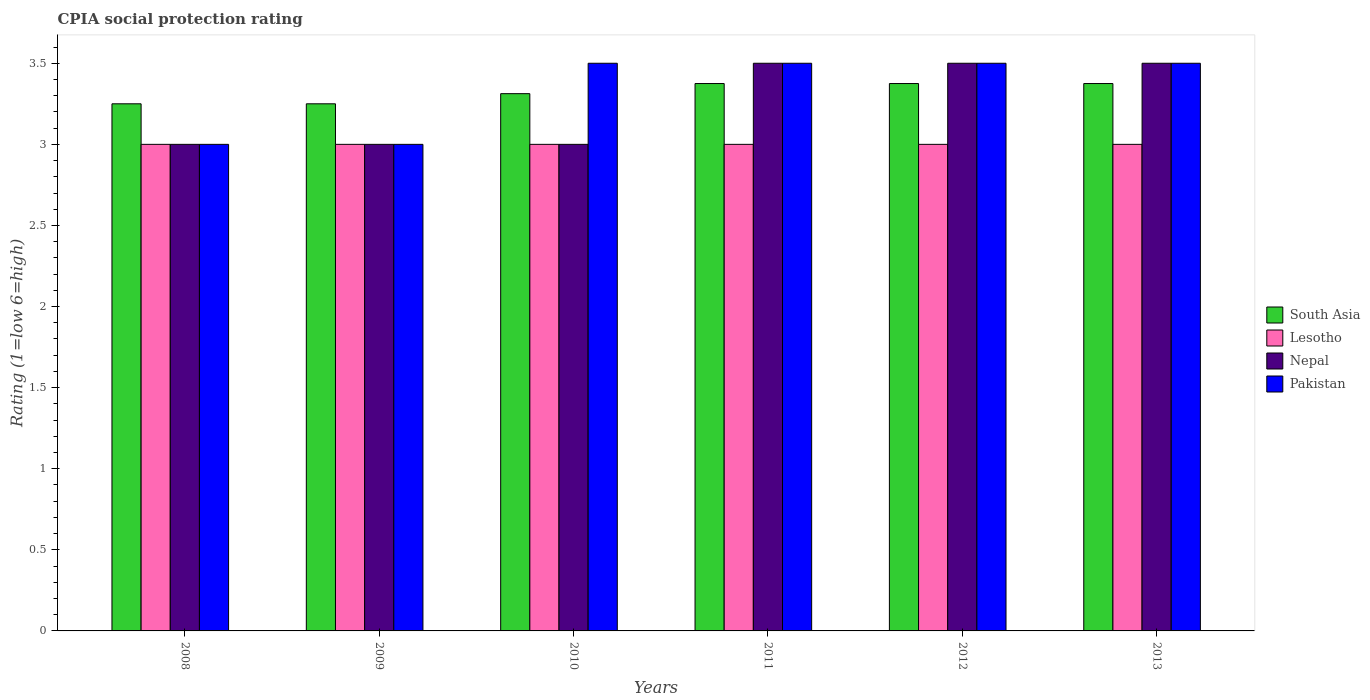How many groups of bars are there?
Your answer should be compact. 6. Are the number of bars per tick equal to the number of legend labels?
Ensure brevity in your answer.  Yes. How many bars are there on the 6th tick from the left?
Give a very brief answer. 4. What is the label of the 6th group of bars from the left?
Give a very brief answer. 2013. In how many cases, is the number of bars for a given year not equal to the number of legend labels?
Provide a succinct answer. 0. What is the CPIA rating in South Asia in 2013?
Give a very brief answer. 3.38. Across all years, what is the minimum CPIA rating in Lesotho?
Offer a very short reply. 3. In which year was the CPIA rating in Pakistan maximum?
Ensure brevity in your answer.  2010. What is the total CPIA rating in South Asia in the graph?
Make the answer very short. 19.94. What is the difference between the CPIA rating in South Asia in 2008 and that in 2012?
Your answer should be very brief. -0.12. What is the difference between the CPIA rating in Pakistan in 2011 and the CPIA rating in Nepal in 2009?
Your response must be concise. 0.5. What is the average CPIA rating in South Asia per year?
Offer a terse response. 3.32. In the year 2009, what is the difference between the CPIA rating in Lesotho and CPIA rating in Nepal?
Ensure brevity in your answer.  0. In how many years, is the CPIA rating in Pakistan greater than 2.3?
Offer a very short reply. 6. What is the ratio of the CPIA rating in Pakistan in 2010 to that in 2012?
Offer a very short reply. 1. What is the difference between the highest and the lowest CPIA rating in Pakistan?
Keep it short and to the point. 0.5. In how many years, is the CPIA rating in Lesotho greater than the average CPIA rating in Lesotho taken over all years?
Make the answer very short. 0. Is the sum of the CPIA rating in Lesotho in 2008 and 2011 greater than the maximum CPIA rating in Pakistan across all years?
Give a very brief answer. Yes. What does the 1st bar from the left in 2012 represents?
Your response must be concise. South Asia. What does the 1st bar from the right in 2009 represents?
Provide a short and direct response. Pakistan. Is it the case that in every year, the sum of the CPIA rating in Pakistan and CPIA rating in Lesotho is greater than the CPIA rating in South Asia?
Provide a short and direct response. Yes. How many years are there in the graph?
Your answer should be compact. 6. What is the difference between two consecutive major ticks on the Y-axis?
Provide a succinct answer. 0.5. How many legend labels are there?
Give a very brief answer. 4. What is the title of the graph?
Your answer should be compact. CPIA social protection rating. What is the Rating (1=low 6=high) in Pakistan in 2008?
Make the answer very short. 3. What is the Rating (1=low 6=high) of South Asia in 2009?
Your response must be concise. 3.25. What is the Rating (1=low 6=high) of South Asia in 2010?
Offer a terse response. 3.31. What is the Rating (1=low 6=high) in Lesotho in 2010?
Your response must be concise. 3. What is the Rating (1=low 6=high) in South Asia in 2011?
Your response must be concise. 3.38. What is the Rating (1=low 6=high) in Nepal in 2011?
Offer a terse response. 3.5. What is the Rating (1=low 6=high) of South Asia in 2012?
Offer a very short reply. 3.38. What is the Rating (1=low 6=high) of Nepal in 2012?
Offer a terse response. 3.5. What is the Rating (1=low 6=high) of South Asia in 2013?
Provide a succinct answer. 3.38. What is the Rating (1=low 6=high) in Lesotho in 2013?
Provide a succinct answer. 3. Across all years, what is the maximum Rating (1=low 6=high) of South Asia?
Provide a succinct answer. 3.38. Across all years, what is the maximum Rating (1=low 6=high) in Lesotho?
Keep it short and to the point. 3. Across all years, what is the maximum Rating (1=low 6=high) of Nepal?
Provide a succinct answer. 3.5. Across all years, what is the minimum Rating (1=low 6=high) in South Asia?
Your answer should be very brief. 3.25. Across all years, what is the minimum Rating (1=low 6=high) of Nepal?
Give a very brief answer. 3. What is the total Rating (1=low 6=high) of South Asia in the graph?
Offer a terse response. 19.94. What is the total Rating (1=low 6=high) in Nepal in the graph?
Make the answer very short. 19.5. What is the total Rating (1=low 6=high) in Pakistan in the graph?
Give a very brief answer. 20. What is the difference between the Rating (1=low 6=high) of South Asia in 2008 and that in 2009?
Make the answer very short. 0. What is the difference between the Rating (1=low 6=high) of Nepal in 2008 and that in 2009?
Give a very brief answer. 0. What is the difference between the Rating (1=low 6=high) of South Asia in 2008 and that in 2010?
Make the answer very short. -0.06. What is the difference between the Rating (1=low 6=high) of Lesotho in 2008 and that in 2010?
Give a very brief answer. 0. What is the difference between the Rating (1=low 6=high) of Nepal in 2008 and that in 2010?
Offer a very short reply. 0. What is the difference between the Rating (1=low 6=high) of South Asia in 2008 and that in 2011?
Ensure brevity in your answer.  -0.12. What is the difference between the Rating (1=low 6=high) in South Asia in 2008 and that in 2012?
Provide a succinct answer. -0.12. What is the difference between the Rating (1=low 6=high) in Lesotho in 2008 and that in 2012?
Make the answer very short. 0. What is the difference between the Rating (1=low 6=high) of Pakistan in 2008 and that in 2012?
Give a very brief answer. -0.5. What is the difference between the Rating (1=low 6=high) in South Asia in 2008 and that in 2013?
Offer a very short reply. -0.12. What is the difference between the Rating (1=low 6=high) in South Asia in 2009 and that in 2010?
Give a very brief answer. -0.06. What is the difference between the Rating (1=low 6=high) of Nepal in 2009 and that in 2010?
Give a very brief answer. 0. What is the difference between the Rating (1=low 6=high) in South Asia in 2009 and that in 2011?
Your answer should be very brief. -0.12. What is the difference between the Rating (1=low 6=high) of Lesotho in 2009 and that in 2011?
Offer a very short reply. 0. What is the difference between the Rating (1=low 6=high) of Pakistan in 2009 and that in 2011?
Provide a short and direct response. -0.5. What is the difference between the Rating (1=low 6=high) of South Asia in 2009 and that in 2012?
Ensure brevity in your answer.  -0.12. What is the difference between the Rating (1=low 6=high) of Nepal in 2009 and that in 2012?
Your answer should be compact. -0.5. What is the difference between the Rating (1=low 6=high) in South Asia in 2009 and that in 2013?
Offer a very short reply. -0.12. What is the difference between the Rating (1=low 6=high) of South Asia in 2010 and that in 2011?
Provide a short and direct response. -0.06. What is the difference between the Rating (1=low 6=high) in Lesotho in 2010 and that in 2011?
Keep it short and to the point. 0. What is the difference between the Rating (1=low 6=high) in Nepal in 2010 and that in 2011?
Ensure brevity in your answer.  -0.5. What is the difference between the Rating (1=low 6=high) of Pakistan in 2010 and that in 2011?
Provide a short and direct response. 0. What is the difference between the Rating (1=low 6=high) of South Asia in 2010 and that in 2012?
Keep it short and to the point. -0.06. What is the difference between the Rating (1=low 6=high) of Lesotho in 2010 and that in 2012?
Make the answer very short. 0. What is the difference between the Rating (1=low 6=high) of Nepal in 2010 and that in 2012?
Your answer should be very brief. -0.5. What is the difference between the Rating (1=low 6=high) in South Asia in 2010 and that in 2013?
Provide a succinct answer. -0.06. What is the difference between the Rating (1=low 6=high) in South Asia in 2011 and that in 2012?
Your response must be concise. 0. What is the difference between the Rating (1=low 6=high) of Lesotho in 2011 and that in 2012?
Give a very brief answer. 0. What is the difference between the Rating (1=low 6=high) of Pakistan in 2011 and that in 2012?
Offer a very short reply. 0. What is the difference between the Rating (1=low 6=high) of South Asia in 2011 and that in 2013?
Offer a terse response. 0. What is the difference between the Rating (1=low 6=high) in Pakistan in 2011 and that in 2013?
Offer a very short reply. 0. What is the difference between the Rating (1=low 6=high) in Lesotho in 2012 and that in 2013?
Offer a very short reply. 0. What is the difference between the Rating (1=low 6=high) of Pakistan in 2012 and that in 2013?
Keep it short and to the point. 0. What is the difference between the Rating (1=low 6=high) of South Asia in 2008 and the Rating (1=low 6=high) of Nepal in 2009?
Provide a succinct answer. 0.25. What is the difference between the Rating (1=low 6=high) in Lesotho in 2008 and the Rating (1=low 6=high) in Nepal in 2009?
Provide a short and direct response. 0. What is the difference between the Rating (1=low 6=high) of Nepal in 2008 and the Rating (1=low 6=high) of Pakistan in 2009?
Make the answer very short. 0. What is the difference between the Rating (1=low 6=high) of South Asia in 2008 and the Rating (1=low 6=high) of Lesotho in 2010?
Provide a succinct answer. 0.25. What is the difference between the Rating (1=low 6=high) of South Asia in 2008 and the Rating (1=low 6=high) of Nepal in 2010?
Your response must be concise. 0.25. What is the difference between the Rating (1=low 6=high) in South Asia in 2008 and the Rating (1=low 6=high) in Lesotho in 2011?
Your answer should be very brief. 0.25. What is the difference between the Rating (1=low 6=high) of South Asia in 2008 and the Rating (1=low 6=high) of Pakistan in 2011?
Provide a succinct answer. -0.25. What is the difference between the Rating (1=low 6=high) of Lesotho in 2008 and the Rating (1=low 6=high) of Nepal in 2011?
Your response must be concise. -0.5. What is the difference between the Rating (1=low 6=high) of Nepal in 2008 and the Rating (1=low 6=high) of Pakistan in 2011?
Provide a succinct answer. -0.5. What is the difference between the Rating (1=low 6=high) of Lesotho in 2008 and the Rating (1=low 6=high) of Nepal in 2012?
Offer a very short reply. -0.5. What is the difference between the Rating (1=low 6=high) of Lesotho in 2008 and the Rating (1=low 6=high) of Pakistan in 2012?
Your answer should be compact. -0.5. What is the difference between the Rating (1=low 6=high) of South Asia in 2008 and the Rating (1=low 6=high) of Nepal in 2013?
Keep it short and to the point. -0.25. What is the difference between the Rating (1=low 6=high) in South Asia in 2008 and the Rating (1=low 6=high) in Pakistan in 2013?
Make the answer very short. -0.25. What is the difference between the Rating (1=low 6=high) in Lesotho in 2008 and the Rating (1=low 6=high) in Nepal in 2013?
Keep it short and to the point. -0.5. What is the difference between the Rating (1=low 6=high) of Lesotho in 2008 and the Rating (1=low 6=high) of Pakistan in 2013?
Give a very brief answer. -0.5. What is the difference between the Rating (1=low 6=high) in South Asia in 2009 and the Rating (1=low 6=high) in Lesotho in 2010?
Your response must be concise. 0.25. What is the difference between the Rating (1=low 6=high) of South Asia in 2009 and the Rating (1=low 6=high) of Nepal in 2010?
Give a very brief answer. 0.25. What is the difference between the Rating (1=low 6=high) of South Asia in 2009 and the Rating (1=low 6=high) of Pakistan in 2010?
Offer a very short reply. -0.25. What is the difference between the Rating (1=low 6=high) of Lesotho in 2009 and the Rating (1=low 6=high) of Nepal in 2010?
Provide a succinct answer. 0. What is the difference between the Rating (1=low 6=high) of Nepal in 2009 and the Rating (1=low 6=high) of Pakistan in 2010?
Offer a very short reply. -0.5. What is the difference between the Rating (1=low 6=high) in South Asia in 2009 and the Rating (1=low 6=high) in Nepal in 2011?
Make the answer very short. -0.25. What is the difference between the Rating (1=low 6=high) in South Asia in 2009 and the Rating (1=low 6=high) in Pakistan in 2011?
Provide a short and direct response. -0.25. What is the difference between the Rating (1=low 6=high) of Nepal in 2009 and the Rating (1=low 6=high) of Pakistan in 2012?
Offer a terse response. -0.5. What is the difference between the Rating (1=low 6=high) of South Asia in 2009 and the Rating (1=low 6=high) of Nepal in 2013?
Keep it short and to the point. -0.25. What is the difference between the Rating (1=low 6=high) of South Asia in 2009 and the Rating (1=low 6=high) of Pakistan in 2013?
Your response must be concise. -0.25. What is the difference between the Rating (1=low 6=high) in Lesotho in 2009 and the Rating (1=low 6=high) in Nepal in 2013?
Provide a succinct answer. -0.5. What is the difference between the Rating (1=low 6=high) in Lesotho in 2009 and the Rating (1=low 6=high) in Pakistan in 2013?
Offer a terse response. -0.5. What is the difference between the Rating (1=low 6=high) of South Asia in 2010 and the Rating (1=low 6=high) of Lesotho in 2011?
Ensure brevity in your answer.  0.31. What is the difference between the Rating (1=low 6=high) of South Asia in 2010 and the Rating (1=low 6=high) of Nepal in 2011?
Provide a short and direct response. -0.19. What is the difference between the Rating (1=low 6=high) in South Asia in 2010 and the Rating (1=low 6=high) in Pakistan in 2011?
Offer a very short reply. -0.19. What is the difference between the Rating (1=low 6=high) of Lesotho in 2010 and the Rating (1=low 6=high) of Pakistan in 2011?
Your answer should be very brief. -0.5. What is the difference between the Rating (1=low 6=high) in South Asia in 2010 and the Rating (1=low 6=high) in Lesotho in 2012?
Provide a succinct answer. 0.31. What is the difference between the Rating (1=low 6=high) in South Asia in 2010 and the Rating (1=low 6=high) in Nepal in 2012?
Keep it short and to the point. -0.19. What is the difference between the Rating (1=low 6=high) of South Asia in 2010 and the Rating (1=low 6=high) of Pakistan in 2012?
Offer a terse response. -0.19. What is the difference between the Rating (1=low 6=high) in Lesotho in 2010 and the Rating (1=low 6=high) in Pakistan in 2012?
Your answer should be very brief. -0.5. What is the difference between the Rating (1=low 6=high) of Nepal in 2010 and the Rating (1=low 6=high) of Pakistan in 2012?
Give a very brief answer. -0.5. What is the difference between the Rating (1=low 6=high) in South Asia in 2010 and the Rating (1=low 6=high) in Lesotho in 2013?
Your answer should be very brief. 0.31. What is the difference between the Rating (1=low 6=high) in South Asia in 2010 and the Rating (1=low 6=high) in Nepal in 2013?
Provide a short and direct response. -0.19. What is the difference between the Rating (1=low 6=high) of South Asia in 2010 and the Rating (1=low 6=high) of Pakistan in 2013?
Keep it short and to the point. -0.19. What is the difference between the Rating (1=low 6=high) in South Asia in 2011 and the Rating (1=low 6=high) in Lesotho in 2012?
Your response must be concise. 0.38. What is the difference between the Rating (1=low 6=high) in South Asia in 2011 and the Rating (1=low 6=high) in Nepal in 2012?
Keep it short and to the point. -0.12. What is the difference between the Rating (1=low 6=high) in South Asia in 2011 and the Rating (1=low 6=high) in Pakistan in 2012?
Keep it short and to the point. -0.12. What is the difference between the Rating (1=low 6=high) of Lesotho in 2011 and the Rating (1=low 6=high) of Nepal in 2012?
Your answer should be compact. -0.5. What is the difference between the Rating (1=low 6=high) in South Asia in 2011 and the Rating (1=low 6=high) in Nepal in 2013?
Make the answer very short. -0.12. What is the difference between the Rating (1=low 6=high) in South Asia in 2011 and the Rating (1=low 6=high) in Pakistan in 2013?
Provide a short and direct response. -0.12. What is the difference between the Rating (1=low 6=high) in Lesotho in 2011 and the Rating (1=low 6=high) in Nepal in 2013?
Provide a succinct answer. -0.5. What is the difference between the Rating (1=low 6=high) in Lesotho in 2011 and the Rating (1=low 6=high) in Pakistan in 2013?
Make the answer very short. -0.5. What is the difference between the Rating (1=low 6=high) in South Asia in 2012 and the Rating (1=low 6=high) in Nepal in 2013?
Offer a very short reply. -0.12. What is the difference between the Rating (1=low 6=high) of South Asia in 2012 and the Rating (1=low 6=high) of Pakistan in 2013?
Your response must be concise. -0.12. What is the difference between the Rating (1=low 6=high) in Lesotho in 2012 and the Rating (1=low 6=high) in Nepal in 2013?
Your answer should be very brief. -0.5. What is the difference between the Rating (1=low 6=high) in Lesotho in 2012 and the Rating (1=low 6=high) in Pakistan in 2013?
Offer a terse response. -0.5. What is the difference between the Rating (1=low 6=high) in Nepal in 2012 and the Rating (1=low 6=high) in Pakistan in 2013?
Your answer should be compact. 0. What is the average Rating (1=low 6=high) in South Asia per year?
Your answer should be compact. 3.32. What is the average Rating (1=low 6=high) of Nepal per year?
Keep it short and to the point. 3.25. In the year 2008, what is the difference between the Rating (1=low 6=high) in South Asia and Rating (1=low 6=high) in Nepal?
Your response must be concise. 0.25. In the year 2008, what is the difference between the Rating (1=low 6=high) in Nepal and Rating (1=low 6=high) in Pakistan?
Ensure brevity in your answer.  0. In the year 2009, what is the difference between the Rating (1=low 6=high) in South Asia and Rating (1=low 6=high) in Nepal?
Make the answer very short. 0.25. In the year 2009, what is the difference between the Rating (1=low 6=high) of South Asia and Rating (1=low 6=high) of Pakistan?
Offer a terse response. 0.25. In the year 2010, what is the difference between the Rating (1=low 6=high) in South Asia and Rating (1=low 6=high) in Lesotho?
Provide a succinct answer. 0.31. In the year 2010, what is the difference between the Rating (1=low 6=high) in South Asia and Rating (1=low 6=high) in Nepal?
Ensure brevity in your answer.  0.31. In the year 2010, what is the difference between the Rating (1=low 6=high) of South Asia and Rating (1=low 6=high) of Pakistan?
Provide a succinct answer. -0.19. In the year 2010, what is the difference between the Rating (1=low 6=high) in Lesotho and Rating (1=low 6=high) in Pakistan?
Provide a succinct answer. -0.5. In the year 2011, what is the difference between the Rating (1=low 6=high) of South Asia and Rating (1=low 6=high) of Nepal?
Your answer should be very brief. -0.12. In the year 2011, what is the difference between the Rating (1=low 6=high) of South Asia and Rating (1=low 6=high) of Pakistan?
Offer a terse response. -0.12. In the year 2011, what is the difference between the Rating (1=low 6=high) of Lesotho and Rating (1=low 6=high) of Nepal?
Provide a succinct answer. -0.5. In the year 2011, what is the difference between the Rating (1=low 6=high) in Lesotho and Rating (1=low 6=high) in Pakistan?
Make the answer very short. -0.5. In the year 2012, what is the difference between the Rating (1=low 6=high) of South Asia and Rating (1=low 6=high) of Lesotho?
Offer a very short reply. 0.38. In the year 2012, what is the difference between the Rating (1=low 6=high) in South Asia and Rating (1=low 6=high) in Nepal?
Ensure brevity in your answer.  -0.12. In the year 2012, what is the difference between the Rating (1=low 6=high) of South Asia and Rating (1=low 6=high) of Pakistan?
Give a very brief answer. -0.12. In the year 2013, what is the difference between the Rating (1=low 6=high) in South Asia and Rating (1=low 6=high) in Lesotho?
Your response must be concise. 0.38. In the year 2013, what is the difference between the Rating (1=low 6=high) in South Asia and Rating (1=low 6=high) in Nepal?
Your answer should be very brief. -0.12. In the year 2013, what is the difference between the Rating (1=low 6=high) in South Asia and Rating (1=low 6=high) in Pakistan?
Offer a terse response. -0.12. In the year 2013, what is the difference between the Rating (1=low 6=high) of Nepal and Rating (1=low 6=high) of Pakistan?
Keep it short and to the point. 0. What is the ratio of the Rating (1=low 6=high) in South Asia in 2008 to that in 2009?
Offer a very short reply. 1. What is the ratio of the Rating (1=low 6=high) of Pakistan in 2008 to that in 2009?
Offer a terse response. 1. What is the ratio of the Rating (1=low 6=high) in South Asia in 2008 to that in 2010?
Ensure brevity in your answer.  0.98. What is the ratio of the Rating (1=low 6=high) of Lesotho in 2008 to that in 2010?
Your response must be concise. 1. What is the ratio of the Rating (1=low 6=high) in Pakistan in 2008 to that in 2010?
Your answer should be very brief. 0.86. What is the ratio of the Rating (1=low 6=high) of Lesotho in 2008 to that in 2011?
Your response must be concise. 1. What is the ratio of the Rating (1=low 6=high) in Nepal in 2008 to that in 2011?
Keep it short and to the point. 0.86. What is the ratio of the Rating (1=low 6=high) of Pakistan in 2008 to that in 2011?
Make the answer very short. 0.86. What is the ratio of the Rating (1=low 6=high) of Nepal in 2008 to that in 2012?
Keep it short and to the point. 0.86. What is the ratio of the Rating (1=low 6=high) in Nepal in 2008 to that in 2013?
Provide a succinct answer. 0.86. What is the ratio of the Rating (1=low 6=high) of Pakistan in 2008 to that in 2013?
Provide a succinct answer. 0.86. What is the ratio of the Rating (1=low 6=high) in South Asia in 2009 to that in 2010?
Your response must be concise. 0.98. What is the ratio of the Rating (1=low 6=high) of Nepal in 2009 to that in 2010?
Keep it short and to the point. 1. What is the ratio of the Rating (1=low 6=high) of Lesotho in 2009 to that in 2011?
Your answer should be very brief. 1. What is the ratio of the Rating (1=low 6=high) in Nepal in 2009 to that in 2011?
Provide a short and direct response. 0.86. What is the ratio of the Rating (1=low 6=high) of Pakistan in 2009 to that in 2011?
Give a very brief answer. 0.86. What is the ratio of the Rating (1=low 6=high) in South Asia in 2009 to that in 2012?
Provide a short and direct response. 0.96. What is the ratio of the Rating (1=low 6=high) in Nepal in 2009 to that in 2012?
Make the answer very short. 0.86. What is the ratio of the Rating (1=low 6=high) of South Asia in 2009 to that in 2013?
Make the answer very short. 0.96. What is the ratio of the Rating (1=low 6=high) in South Asia in 2010 to that in 2011?
Ensure brevity in your answer.  0.98. What is the ratio of the Rating (1=low 6=high) of Lesotho in 2010 to that in 2011?
Offer a very short reply. 1. What is the ratio of the Rating (1=low 6=high) in Nepal in 2010 to that in 2011?
Provide a short and direct response. 0.86. What is the ratio of the Rating (1=low 6=high) in South Asia in 2010 to that in 2012?
Your answer should be very brief. 0.98. What is the ratio of the Rating (1=low 6=high) in Nepal in 2010 to that in 2012?
Provide a succinct answer. 0.86. What is the ratio of the Rating (1=low 6=high) of Pakistan in 2010 to that in 2012?
Offer a terse response. 1. What is the ratio of the Rating (1=low 6=high) of South Asia in 2010 to that in 2013?
Ensure brevity in your answer.  0.98. What is the ratio of the Rating (1=low 6=high) in Nepal in 2010 to that in 2013?
Make the answer very short. 0.86. What is the ratio of the Rating (1=low 6=high) of Pakistan in 2010 to that in 2013?
Make the answer very short. 1. What is the ratio of the Rating (1=low 6=high) of South Asia in 2011 to that in 2012?
Your answer should be compact. 1. What is the ratio of the Rating (1=low 6=high) in Lesotho in 2011 to that in 2012?
Your answer should be compact. 1. What is the ratio of the Rating (1=low 6=high) of Nepal in 2011 to that in 2012?
Give a very brief answer. 1. What is the ratio of the Rating (1=low 6=high) of South Asia in 2012 to that in 2013?
Make the answer very short. 1. What is the ratio of the Rating (1=low 6=high) in Lesotho in 2012 to that in 2013?
Your answer should be compact. 1. What is the ratio of the Rating (1=low 6=high) of Pakistan in 2012 to that in 2013?
Provide a succinct answer. 1. What is the difference between the highest and the second highest Rating (1=low 6=high) in Nepal?
Ensure brevity in your answer.  0. What is the difference between the highest and the second highest Rating (1=low 6=high) in Pakistan?
Your response must be concise. 0. What is the difference between the highest and the lowest Rating (1=low 6=high) in South Asia?
Your answer should be very brief. 0.12. What is the difference between the highest and the lowest Rating (1=low 6=high) in Lesotho?
Provide a succinct answer. 0. What is the difference between the highest and the lowest Rating (1=low 6=high) in Nepal?
Your answer should be very brief. 0.5. 